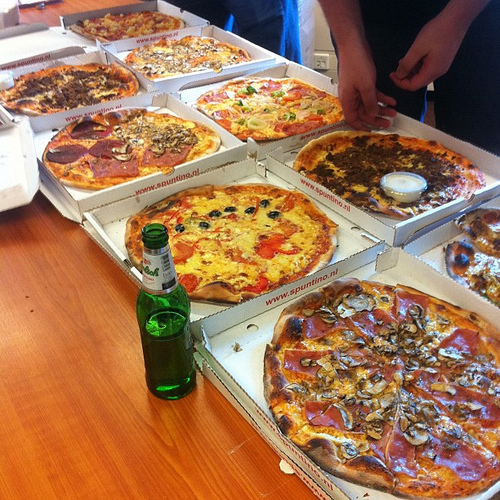Are there any pizzas in the box to the left of the container? Yes, there are pizzas in the box to the left of the container. 